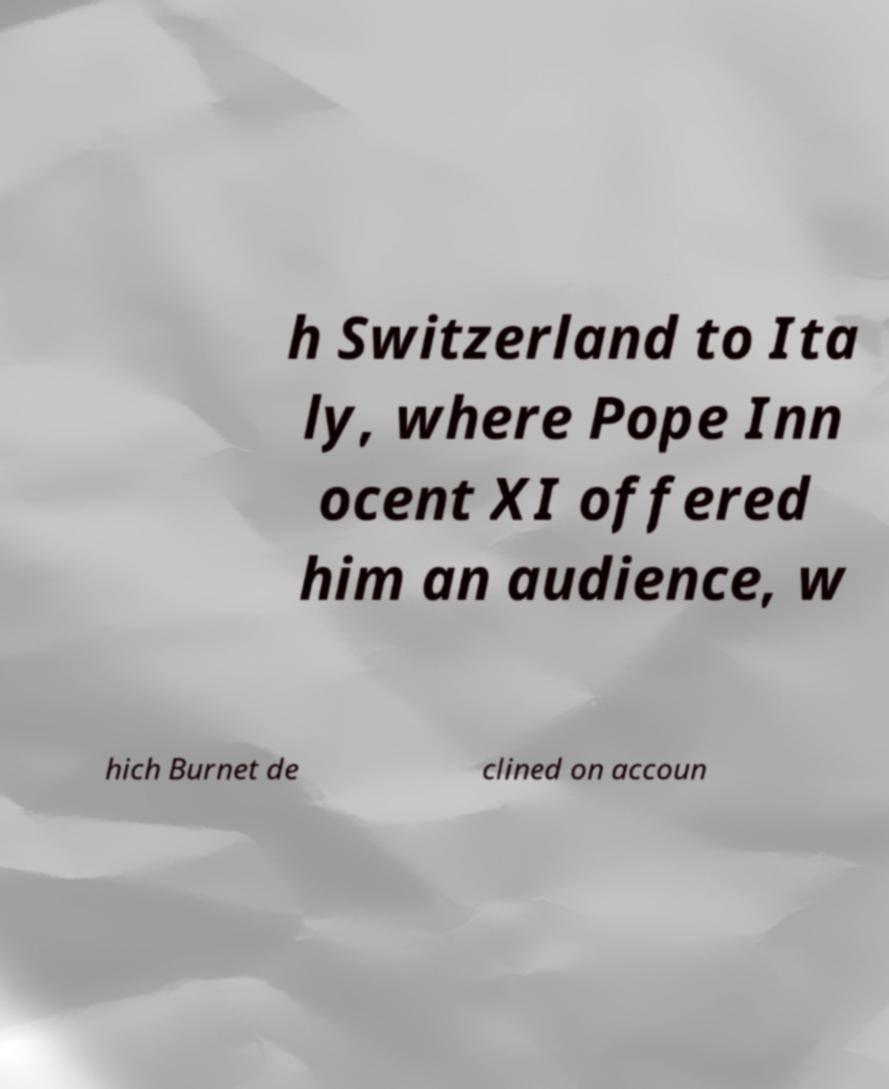Can you accurately transcribe the text from the provided image for me? h Switzerland to Ita ly, where Pope Inn ocent XI offered him an audience, w hich Burnet de clined on accoun 